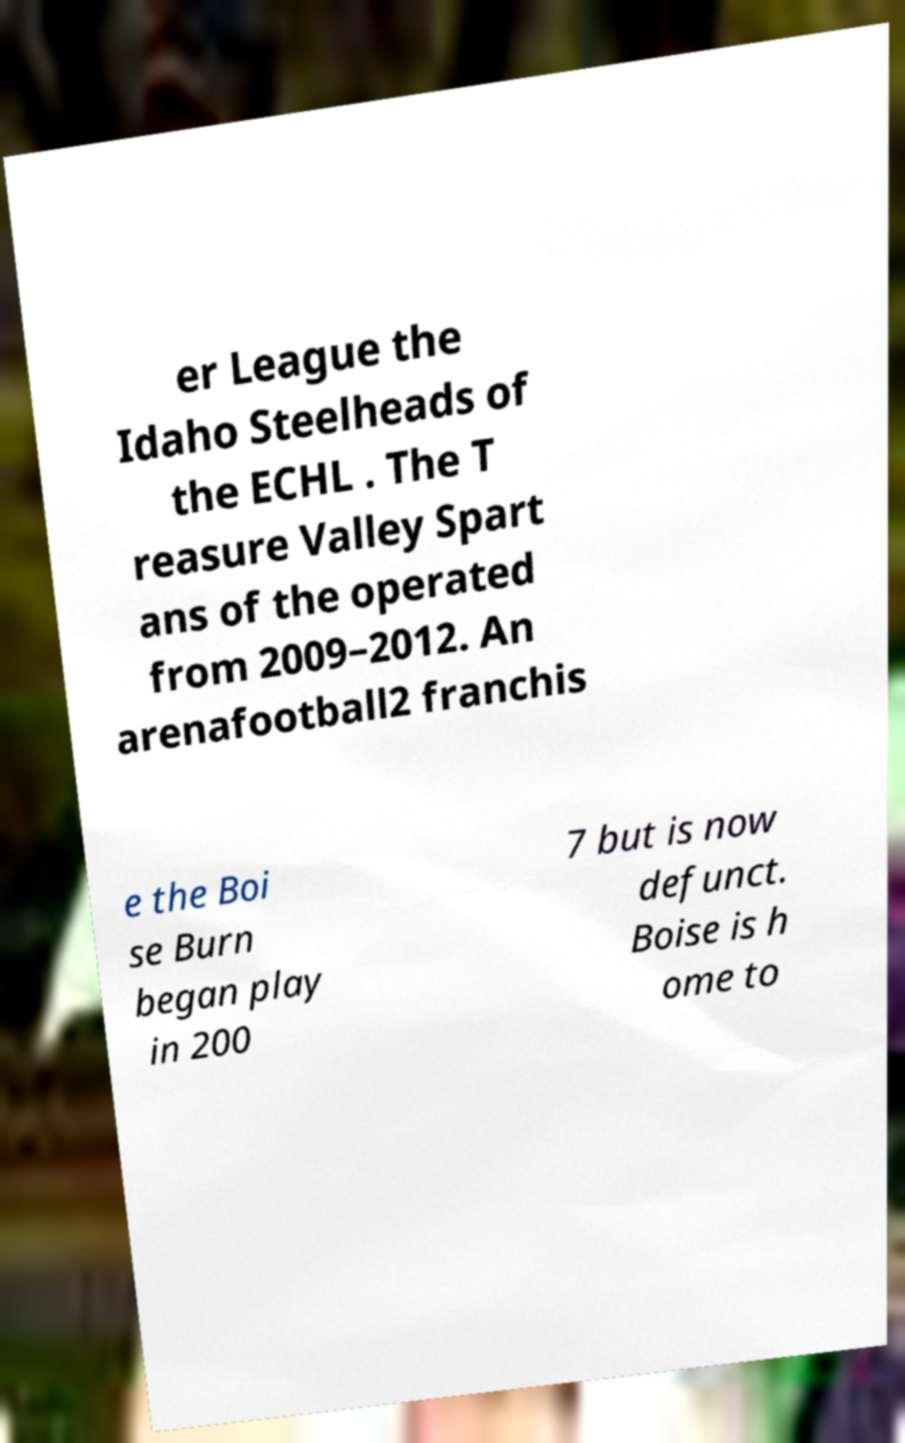Can you read and provide the text displayed in the image?This photo seems to have some interesting text. Can you extract and type it out for me? er League the Idaho Steelheads of the ECHL . The T reasure Valley Spart ans of the operated from 2009–2012. An arenafootball2 franchis e the Boi se Burn began play in 200 7 but is now defunct. Boise is h ome to 